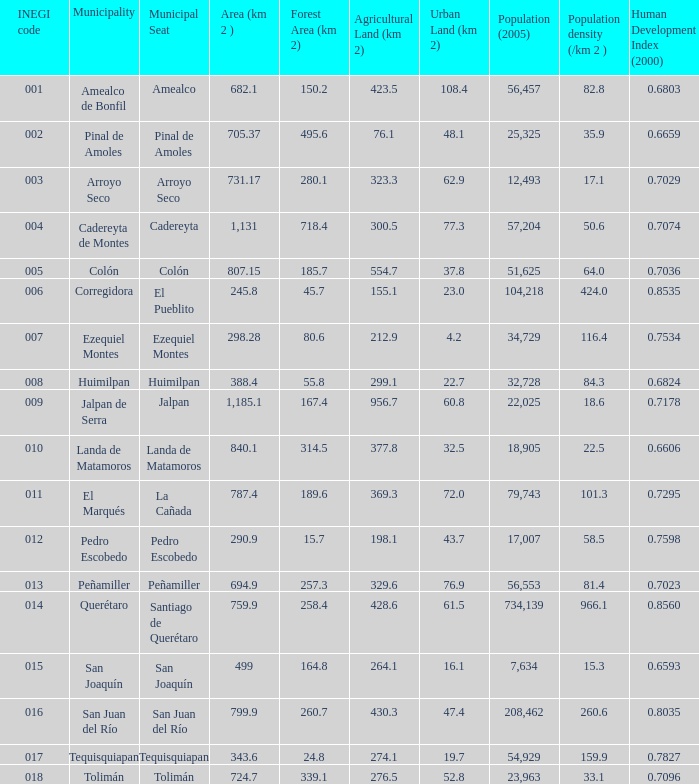WHich INEGI code has a Population density (/km 2 ) smaller than 81.4 and 0.6593 Human Development Index (2000)? 15.0. Help me parse the entirety of this table. {'header': ['INEGI code', 'Municipality', 'Municipal Seat', 'Area (km 2 )', 'Forest Area (km 2)', 'Agricultural Land (km 2)', 'Urban Land (km 2)', 'Population (2005)', 'Population density (/km 2 )', 'Human Development Index (2000)'], 'rows': [['001', 'Amealco de Bonfil', 'Amealco', '682.1', '150.2', '423.5', '108.4', '56,457', '82.8', '0.6803'], ['002', 'Pinal de Amoles', 'Pinal de Amoles', '705.37', '495.6', '76.1', '48.1', '25,325', '35.9', '0.6659'], ['003', 'Arroyo Seco', 'Arroyo Seco', '731.17', '280.1', '323.3', '62.9', '12,493', '17.1', '0.7029'], ['004', 'Cadereyta de Montes', 'Cadereyta', '1,131', '718.4', '300.5', '77.3', '57,204', '50.6', '0.7074'], ['005', 'Colón', 'Colón', '807.15', '185.7', '554.7', '37.8', '51,625', '64.0', '0.7036'], ['006', 'Corregidora', 'El Pueblito', '245.8', '45.7', '155.1', '23.0', '104,218', '424.0', '0.8535'], ['007', 'Ezequiel Montes', 'Ezequiel Montes', '298.28', '80.6', '212.9', '4.2', '34,729', '116.4', '0.7534'], ['008', 'Huimilpan', 'Huimilpan', '388.4', '55.8', '299.1', '22.7', '32,728', '84.3', '0.6824'], ['009', 'Jalpan de Serra', 'Jalpan', '1,185.1', '167.4', '956.7', '60.8', '22,025', '18.6', '0.7178'], ['010', 'Landa de Matamoros', 'Landa de Matamoros', '840.1', '314.5', '377.8', '32.5', '18,905', '22.5', '0.6606'], ['011', 'El Marqués', 'La Cañada', '787.4', '189.6', '369.3', '72.0', '79,743', '101.3', '0.7295'], ['012', 'Pedro Escobedo', 'Pedro Escobedo', '290.9', '15.7', '198.1', '43.7', '17,007', '58.5', '0.7598'], ['013', 'Peñamiller', 'Peñamiller', '694.9', '257.3', '329.6', '76.9', '56,553', '81.4', '0.7023'], ['014', 'Querétaro', 'Santiago de Querétaro', '759.9', '258.4', '428.6', '61.5', '734,139', '966.1', '0.8560'], ['015', 'San Joaquín', 'San Joaquín', '499', '164.8', '264.1', '16.1', '7,634', '15.3', '0.6593'], ['016', 'San Juan del Río', 'San Juan del Río', '799.9', '260.7', '430.3', '47.4', '208,462', '260.6', '0.8035'], ['017', 'Tequisquiapan', 'Tequisquiapan', '343.6', '24.8', '274.1', '19.7', '54,929', '159.9', '0.7827'], ['018', 'Tolimán', 'Tolimán', '724.7', '339.1', '276.5', '52.8', '23,963', '33.1', '0.7096']]} 